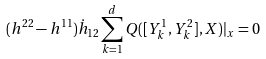<formula> <loc_0><loc_0><loc_500><loc_500>( h ^ { 2 2 } - h ^ { 1 1 } ) \dot { h } _ { 1 2 } \sum _ { k = 1 } ^ { d } Q ( [ Y _ { k } ^ { 1 } , Y _ { k } ^ { 2 } ] , X ) | _ { x } = 0</formula> 